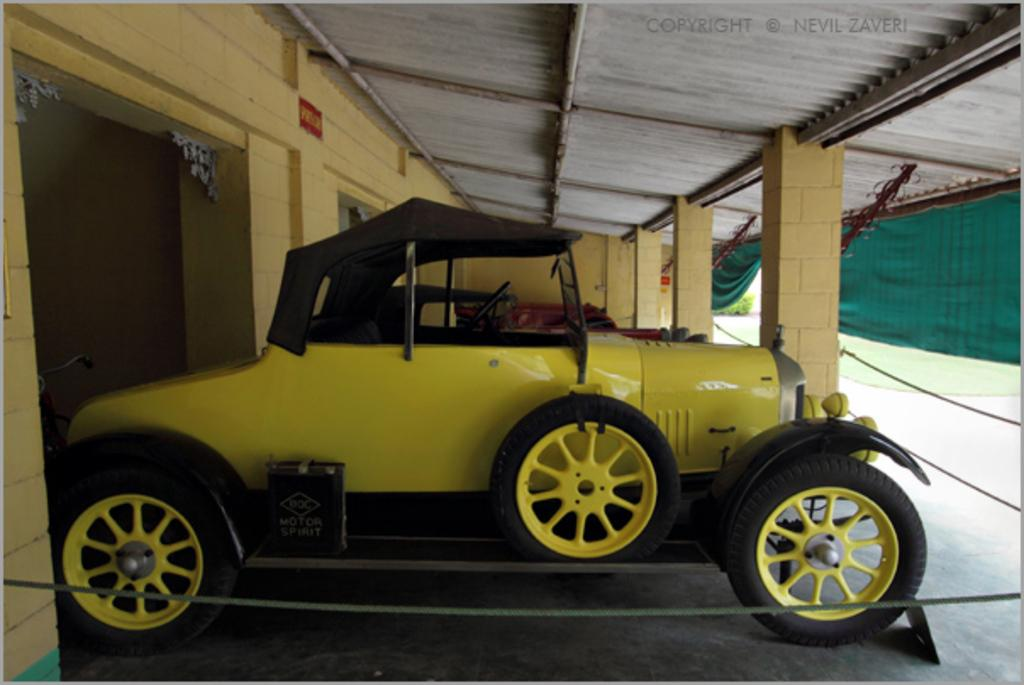What type of vehicles are under the shed in the image? There are cars under the shed in the image. What type of window treatment is present in the image? There are curtains in the image. What material are the rods made of in the image? There are metal rods in the image. What type of organization is hosting a battle in the image? There is no organization or battle present in the image; it features cars under a shed, curtains, and metal rods. What type of hose is being used to water the plants in the image? There are no plants or hoses present in the image. 